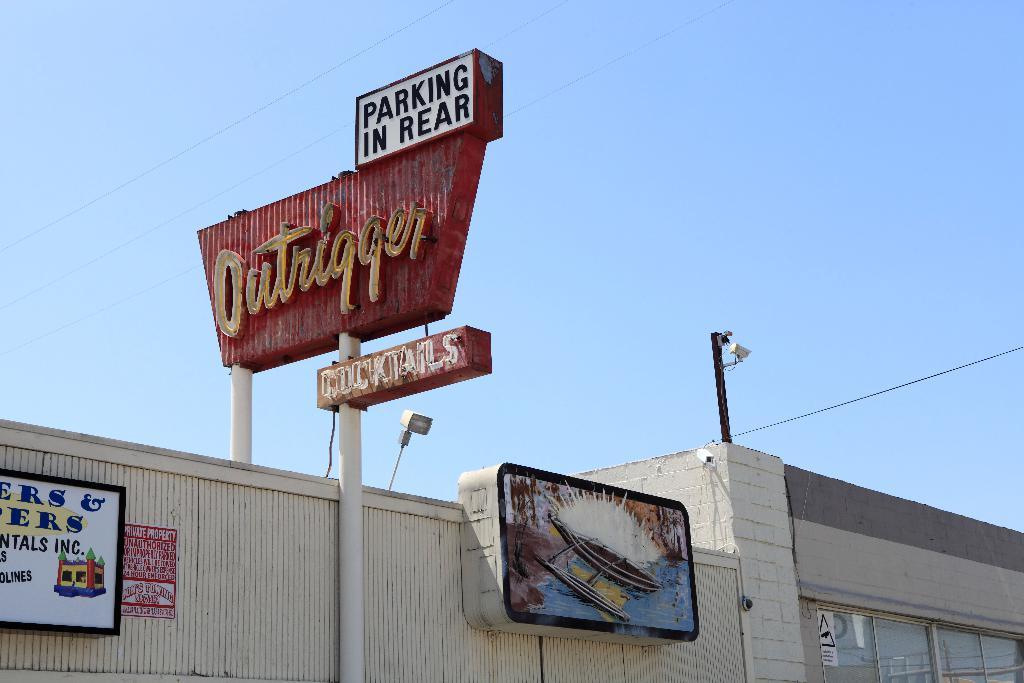Where can you park?
Your answer should be very brief. In rear. 